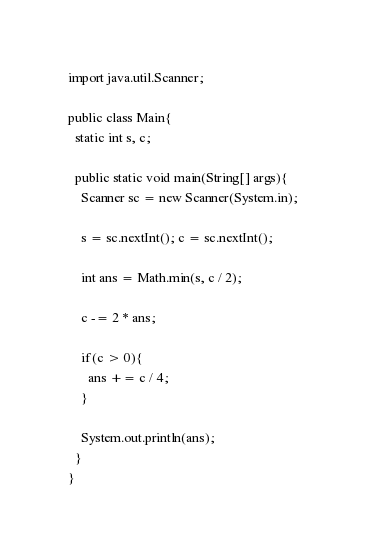Convert code to text. <code><loc_0><loc_0><loc_500><loc_500><_Java_>import java.util.Scanner;

public class Main{
  static int s, c;

  public static void main(String[] args){
    Scanner sc = new Scanner(System.in);

    s = sc.nextInt(); c = sc.nextInt();

    int ans = Math.min(s, c / 2);

    c -= 2 * ans;

    if(c > 0){
      ans += c / 4;
    }

    System.out.println(ans);
  }
}
</code> 